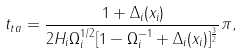Convert formula to latex. <formula><loc_0><loc_0><loc_500><loc_500>t _ { t a } = \frac { 1 + \Delta _ { i } ( x _ { i } ) } { 2 H _ { i } \Omega ^ { 1 / 2 } _ { i } [ 1 - \Omega ^ { - 1 } _ { i } + \Delta _ { i } ( x _ { i } ) ] ^ { \frac { 3 } { 2 } } } \pi , \\</formula> 